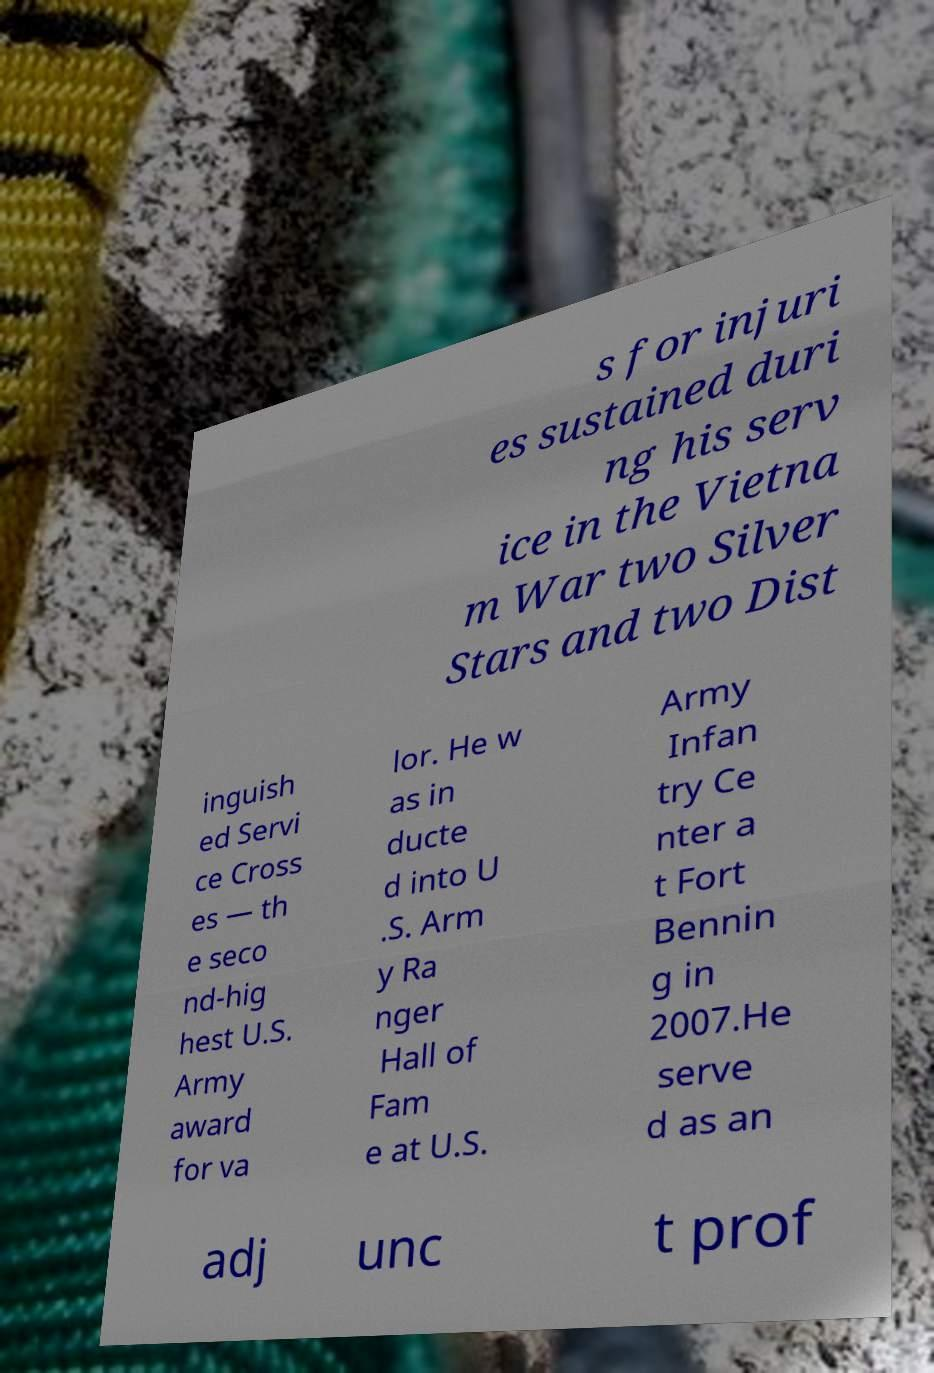Could you extract and type out the text from this image? s for injuri es sustained duri ng his serv ice in the Vietna m War two Silver Stars and two Dist inguish ed Servi ce Cross es — th e seco nd-hig hest U.S. Army award for va lor. He w as in ducte d into U .S. Arm y Ra nger Hall of Fam e at U.S. Army Infan try Ce nter a t Fort Bennin g in 2007.He serve d as an adj unc t prof 